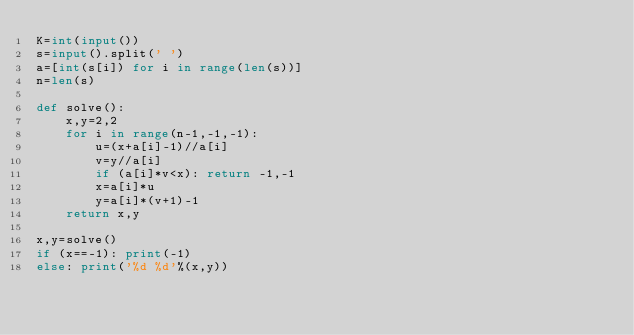<code> <loc_0><loc_0><loc_500><loc_500><_Python_>K=int(input())
s=input().split(' ')
a=[int(s[i]) for i in range(len(s))]
n=len(s)

def solve():
	x,y=2,2
	for i in range(n-1,-1,-1):
		u=(x+a[i]-1)//a[i]
		v=y//a[i]
		if (a[i]*v<x): return -1,-1
		x=a[i]*u
		y=a[i]*(v+1)-1
	return x,y

x,y=solve()
if (x==-1): print(-1)
else: print('%d %d'%(x,y))</code> 